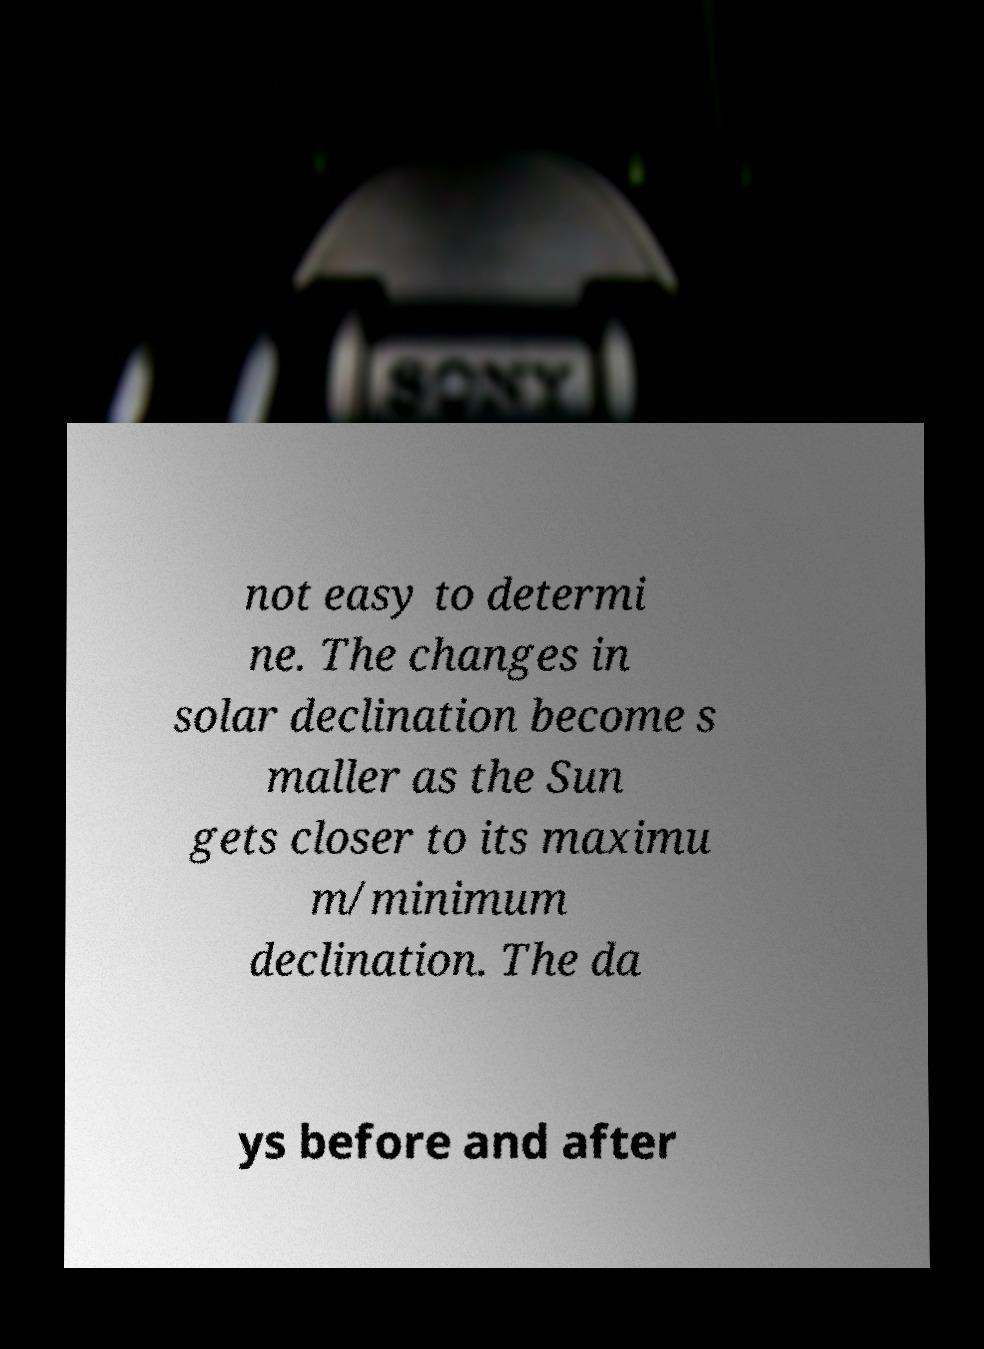For documentation purposes, I need the text within this image transcribed. Could you provide that? not easy to determi ne. The changes in solar declination become s maller as the Sun gets closer to its maximu m/minimum declination. The da ys before and after 